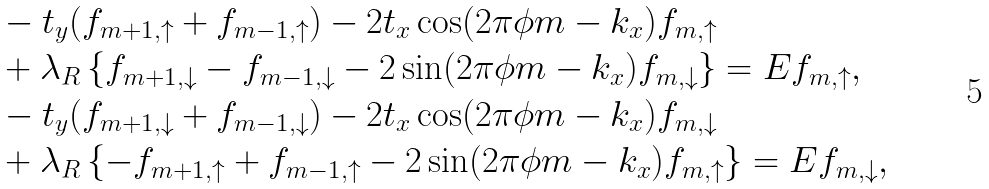<formula> <loc_0><loc_0><loc_500><loc_500>& - t _ { y } ( f _ { m + 1 , \uparrow } + f _ { m - 1 , \uparrow } ) - 2 t _ { x } \cos ( 2 \pi \phi m - k _ { x } ) f _ { m , \uparrow } \\ & + \lambda _ { R } \left \{ f _ { m + 1 , \downarrow } - f _ { m - 1 , \downarrow } - 2 \sin ( 2 \pi \phi m - k _ { x } ) f _ { m , \downarrow } \right \} = E f _ { m , \uparrow } , \\ & - t _ { y } ( f _ { m + 1 , \downarrow } + f _ { m - 1 , \downarrow } ) - 2 t _ { x } \cos ( 2 \pi \phi m - k _ { x } ) f _ { m , \downarrow } \\ & + \lambda _ { R } \left \{ - f _ { m + 1 , \uparrow } + f _ { m - 1 , \uparrow } - 2 \sin ( 2 \pi \phi m - k _ { x } ) f _ { m , \uparrow } \right \} = E f _ { m , \downarrow } ,</formula> 